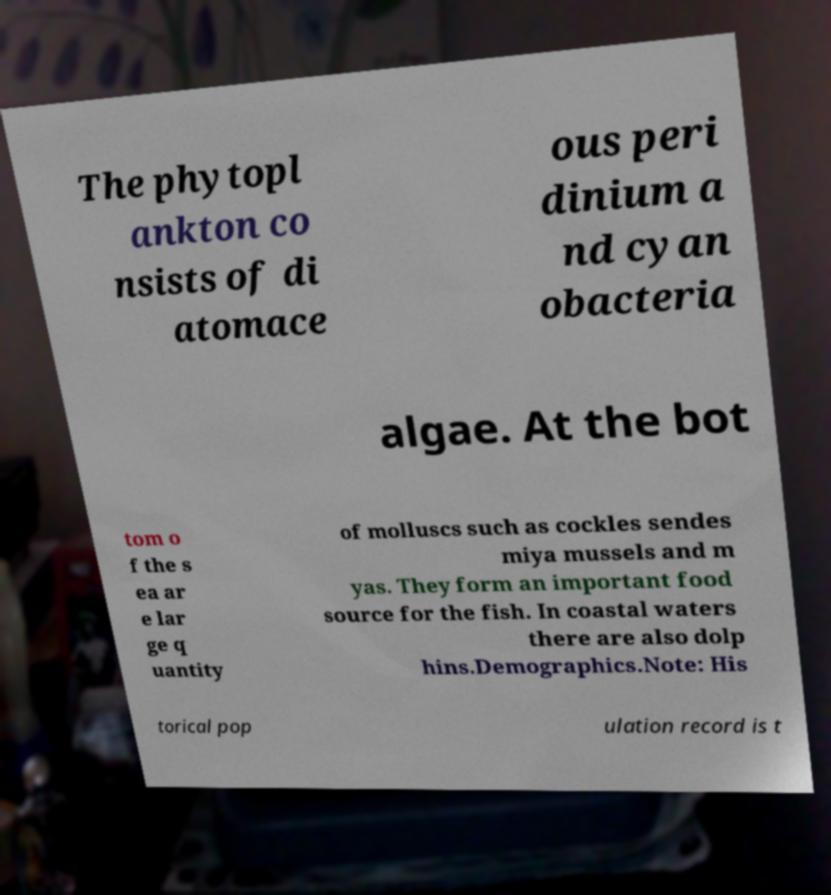Can you accurately transcribe the text from the provided image for me? The phytopl ankton co nsists of di atomace ous peri dinium a nd cyan obacteria algae. At the bot tom o f the s ea ar e lar ge q uantity of molluscs such as cockles sendes miya mussels and m yas. They form an important food source for the fish. In coastal waters there are also dolp hins.Demographics.Note: His torical pop ulation record is t 